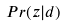<formula> <loc_0><loc_0><loc_500><loc_500>P r ( z | d )</formula> 